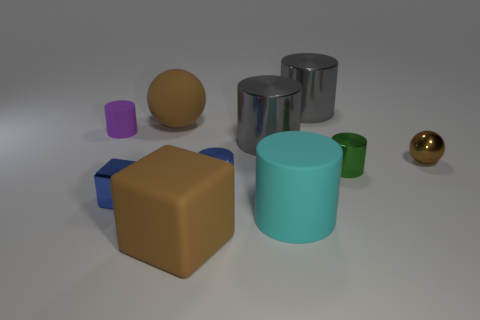The colors are quite varied. Why do you think the creator chose these colors? The varied color palette could be intentional to distinguish between each object, potentially to showcase a range of colors in a design proposal, or simply for visual appeal. The choice can also be driven by the need to show how different materials and surfaces reflect or absorb light. 